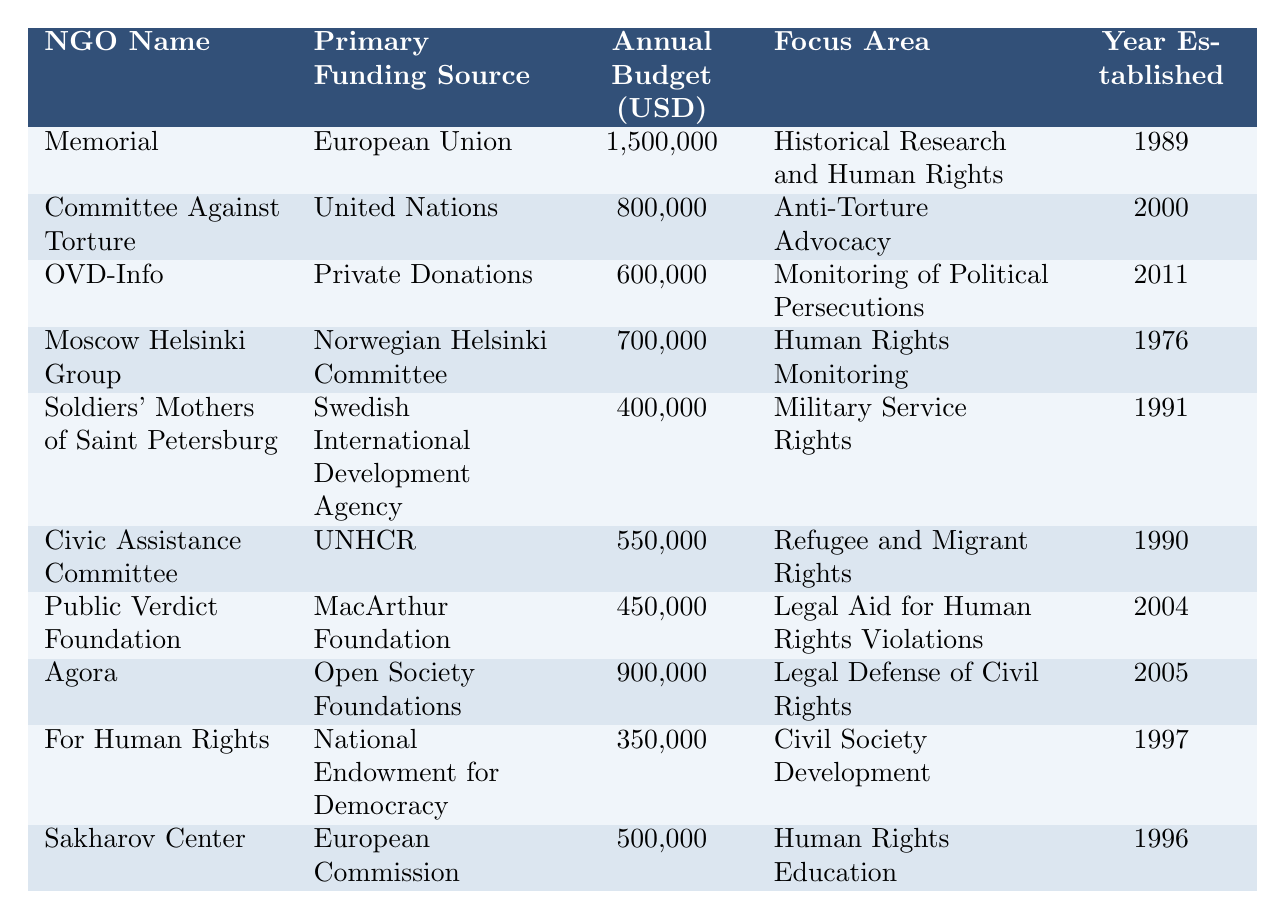What is the primary funding source for OVD-Info? The table shows that OVD-Info's primary funding source is Private Donations.
Answer: Private Donations Which NGO has the largest annual budget? By comparing the annual budgets listed, Memorial has the largest annual budget of 1,500,000 USD.
Answer: Memorial True or False: The Moscow Helsinki Group focuses on Military Service Rights. The table indicates that the Moscow Helsinki Group focuses on Human Rights Monitoring, not Military Service Rights.
Answer: False What is the total annual budget for the NGOs funded by the European Union? The European Union funds Memorial with a budget of 1,500,000 USD and Sakharov Center with a budget of 500,000 USD. Adding these gives 1,500,000 + 500,000 = 2,000,000 USD.
Answer: 2,000,000 Which NGO was established first, the Civic Assistance Committee or the Soldiers' Mothers of Saint Petersburg? The Civic Assistance Committee was established in 1990 and the Soldiers' Mothers of Saint Petersburg in 1991. Thus, the Civic Assistance Committee was established first.
Answer: Civic Assistance Committee What is the focus area of the Public Verdict Foundation? According to the table, the focus area of Public Verdict Foundation is Legal Aid for Human Rights Violations.
Answer: Legal Aid for Human Rights Violations Which funding source supports NGOs with an annual budget of over 600,000 USD? By examining the table, the NGOs with budgets over 600,000 USD are primarily funded by the European Union, United Nations, Norwegian Helsinki Committee, Open Society Foundations, and MacArthur Foundation.
Answer: European Union, United Nations, Norwegian Helsinki Committee, Open Society Foundations, MacArthur Foundation What percentage of the total budget do the Private Donations constitute? The total budget can be calculated as follows: 1,500,000 + 800,000 + 600,000 + 700,000 + 400,000 + 550,000 + 450,000 + 900,000 + 350,000 + 500,000 = 6,000,000 USD. The budget from Private Donations is 600,000 USD. The percentage is (600,000 / 6,000,000) * 100 = 10%.
Answer: 10% Which NGO focuses on the legal defense of civil rights and what is its annual budget? The table indicates Agora focuses on the legal defense of civil rights and has an annual budget of 900,000 USD.
Answer: Agora, 900,000 USD Is there an NGO focused on anti-torture advocacy, and if so, what is its annual budget? Yes, the Committee Against Torture focuses on anti-torture advocacy, and its annual budget is 800,000 USD.
Answer: Yes, 800,000 USD What is the average annual budget of the NGOs established after 2000? The NGOs established after 2000 are OVD-Info (600,000), Public Verdict Foundation (450,000), Agora (900,000), and the average is (600,000 + 450,000 + 900,000) / 3 = 650,000 USD.
Answer: 650,000 